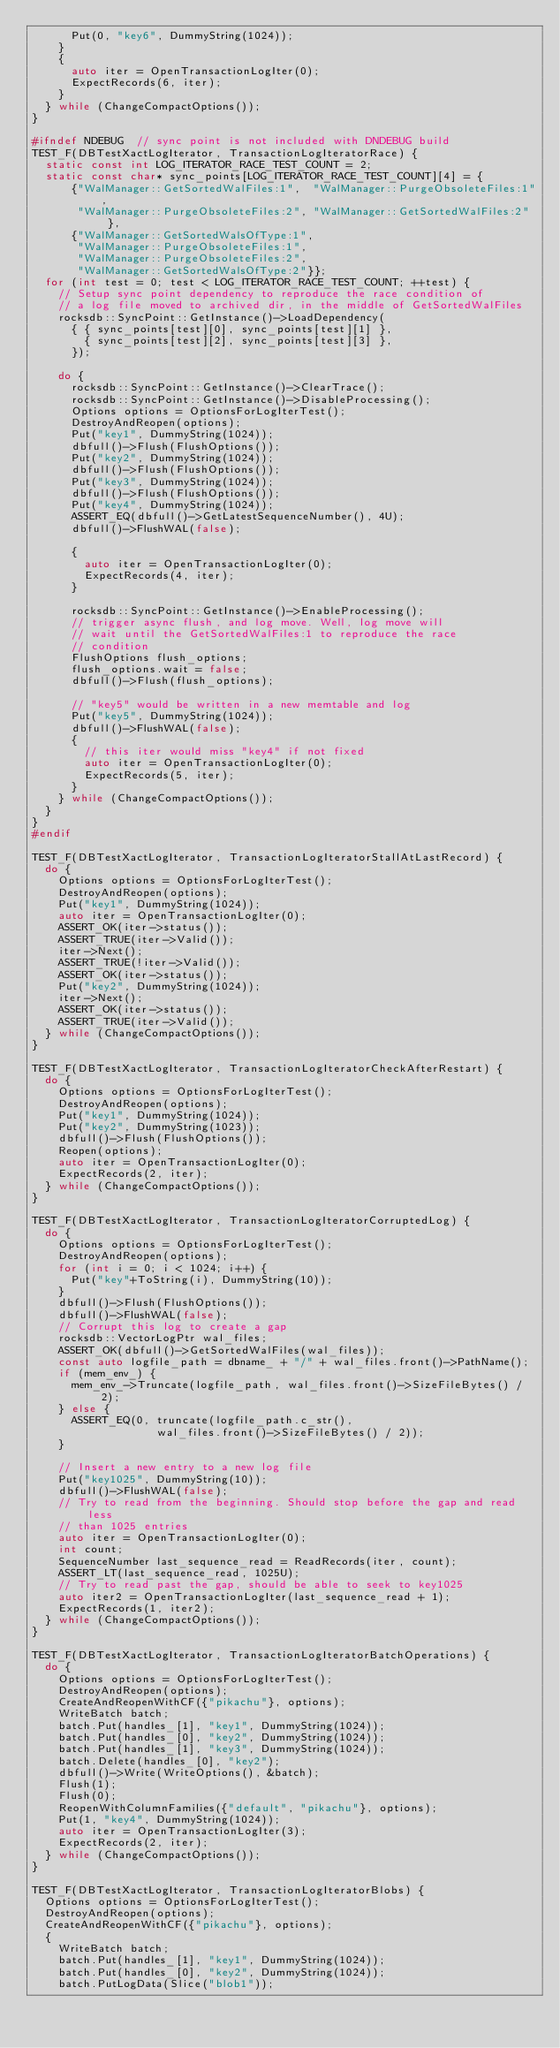<code> <loc_0><loc_0><loc_500><loc_500><_C++_>      Put(0, "key6", DummyString(1024));
    }
    {
      auto iter = OpenTransactionLogIter(0);
      ExpectRecords(6, iter);
    }
  } while (ChangeCompactOptions());
}

#ifndef NDEBUG  // sync point is not included with DNDEBUG build
TEST_F(DBTestXactLogIterator, TransactionLogIteratorRace) {
  static const int LOG_ITERATOR_RACE_TEST_COUNT = 2;
  static const char* sync_points[LOG_ITERATOR_RACE_TEST_COUNT][4] = {
      {"WalManager::GetSortedWalFiles:1",  "WalManager::PurgeObsoleteFiles:1",
       "WalManager::PurgeObsoleteFiles:2", "WalManager::GetSortedWalFiles:2"},
      {"WalManager::GetSortedWalsOfType:1",
       "WalManager::PurgeObsoleteFiles:1",
       "WalManager::PurgeObsoleteFiles:2",
       "WalManager::GetSortedWalsOfType:2"}};
  for (int test = 0; test < LOG_ITERATOR_RACE_TEST_COUNT; ++test) {
    // Setup sync point dependency to reproduce the race condition of
    // a log file moved to archived dir, in the middle of GetSortedWalFiles
    rocksdb::SyncPoint::GetInstance()->LoadDependency(
      { { sync_points[test][0], sync_points[test][1] },
        { sync_points[test][2], sync_points[test][3] },
      });

    do {
      rocksdb::SyncPoint::GetInstance()->ClearTrace();
      rocksdb::SyncPoint::GetInstance()->DisableProcessing();
      Options options = OptionsForLogIterTest();
      DestroyAndReopen(options);
      Put("key1", DummyString(1024));
      dbfull()->Flush(FlushOptions());
      Put("key2", DummyString(1024));
      dbfull()->Flush(FlushOptions());
      Put("key3", DummyString(1024));
      dbfull()->Flush(FlushOptions());
      Put("key4", DummyString(1024));
      ASSERT_EQ(dbfull()->GetLatestSequenceNumber(), 4U);
      dbfull()->FlushWAL(false);

      {
        auto iter = OpenTransactionLogIter(0);
        ExpectRecords(4, iter);
      }

      rocksdb::SyncPoint::GetInstance()->EnableProcessing();
      // trigger async flush, and log move. Well, log move will
      // wait until the GetSortedWalFiles:1 to reproduce the race
      // condition
      FlushOptions flush_options;
      flush_options.wait = false;
      dbfull()->Flush(flush_options);

      // "key5" would be written in a new memtable and log
      Put("key5", DummyString(1024));
      dbfull()->FlushWAL(false);
      {
        // this iter would miss "key4" if not fixed
        auto iter = OpenTransactionLogIter(0);
        ExpectRecords(5, iter);
      }
    } while (ChangeCompactOptions());
  }
}
#endif

TEST_F(DBTestXactLogIterator, TransactionLogIteratorStallAtLastRecord) {
  do {
    Options options = OptionsForLogIterTest();
    DestroyAndReopen(options);
    Put("key1", DummyString(1024));
    auto iter = OpenTransactionLogIter(0);
    ASSERT_OK(iter->status());
    ASSERT_TRUE(iter->Valid());
    iter->Next();
    ASSERT_TRUE(!iter->Valid());
    ASSERT_OK(iter->status());
    Put("key2", DummyString(1024));
    iter->Next();
    ASSERT_OK(iter->status());
    ASSERT_TRUE(iter->Valid());
  } while (ChangeCompactOptions());
}

TEST_F(DBTestXactLogIterator, TransactionLogIteratorCheckAfterRestart) {
  do {
    Options options = OptionsForLogIterTest();
    DestroyAndReopen(options);
    Put("key1", DummyString(1024));
    Put("key2", DummyString(1023));
    dbfull()->Flush(FlushOptions());
    Reopen(options);
    auto iter = OpenTransactionLogIter(0);
    ExpectRecords(2, iter);
  } while (ChangeCompactOptions());
}

TEST_F(DBTestXactLogIterator, TransactionLogIteratorCorruptedLog) {
  do {
    Options options = OptionsForLogIterTest();
    DestroyAndReopen(options);
    for (int i = 0; i < 1024; i++) {
      Put("key"+ToString(i), DummyString(10));
    }
    dbfull()->Flush(FlushOptions());
    dbfull()->FlushWAL(false);
    // Corrupt this log to create a gap
    rocksdb::VectorLogPtr wal_files;
    ASSERT_OK(dbfull()->GetSortedWalFiles(wal_files));
    const auto logfile_path = dbname_ + "/" + wal_files.front()->PathName();
    if (mem_env_) {
      mem_env_->Truncate(logfile_path, wal_files.front()->SizeFileBytes() / 2);
    } else {
      ASSERT_EQ(0, truncate(logfile_path.c_str(),
                   wal_files.front()->SizeFileBytes() / 2));
    }

    // Insert a new entry to a new log file
    Put("key1025", DummyString(10));
    dbfull()->FlushWAL(false);
    // Try to read from the beginning. Should stop before the gap and read less
    // than 1025 entries
    auto iter = OpenTransactionLogIter(0);
    int count;
    SequenceNumber last_sequence_read = ReadRecords(iter, count);
    ASSERT_LT(last_sequence_read, 1025U);
    // Try to read past the gap, should be able to seek to key1025
    auto iter2 = OpenTransactionLogIter(last_sequence_read + 1);
    ExpectRecords(1, iter2);
  } while (ChangeCompactOptions());
}

TEST_F(DBTestXactLogIterator, TransactionLogIteratorBatchOperations) {
  do {
    Options options = OptionsForLogIterTest();
    DestroyAndReopen(options);
    CreateAndReopenWithCF({"pikachu"}, options);
    WriteBatch batch;
    batch.Put(handles_[1], "key1", DummyString(1024));
    batch.Put(handles_[0], "key2", DummyString(1024));
    batch.Put(handles_[1], "key3", DummyString(1024));
    batch.Delete(handles_[0], "key2");
    dbfull()->Write(WriteOptions(), &batch);
    Flush(1);
    Flush(0);
    ReopenWithColumnFamilies({"default", "pikachu"}, options);
    Put(1, "key4", DummyString(1024));
    auto iter = OpenTransactionLogIter(3);
    ExpectRecords(2, iter);
  } while (ChangeCompactOptions());
}

TEST_F(DBTestXactLogIterator, TransactionLogIteratorBlobs) {
  Options options = OptionsForLogIterTest();
  DestroyAndReopen(options);
  CreateAndReopenWithCF({"pikachu"}, options);
  {
    WriteBatch batch;
    batch.Put(handles_[1], "key1", DummyString(1024));
    batch.Put(handles_[0], "key2", DummyString(1024));
    batch.PutLogData(Slice("blob1"));</code> 